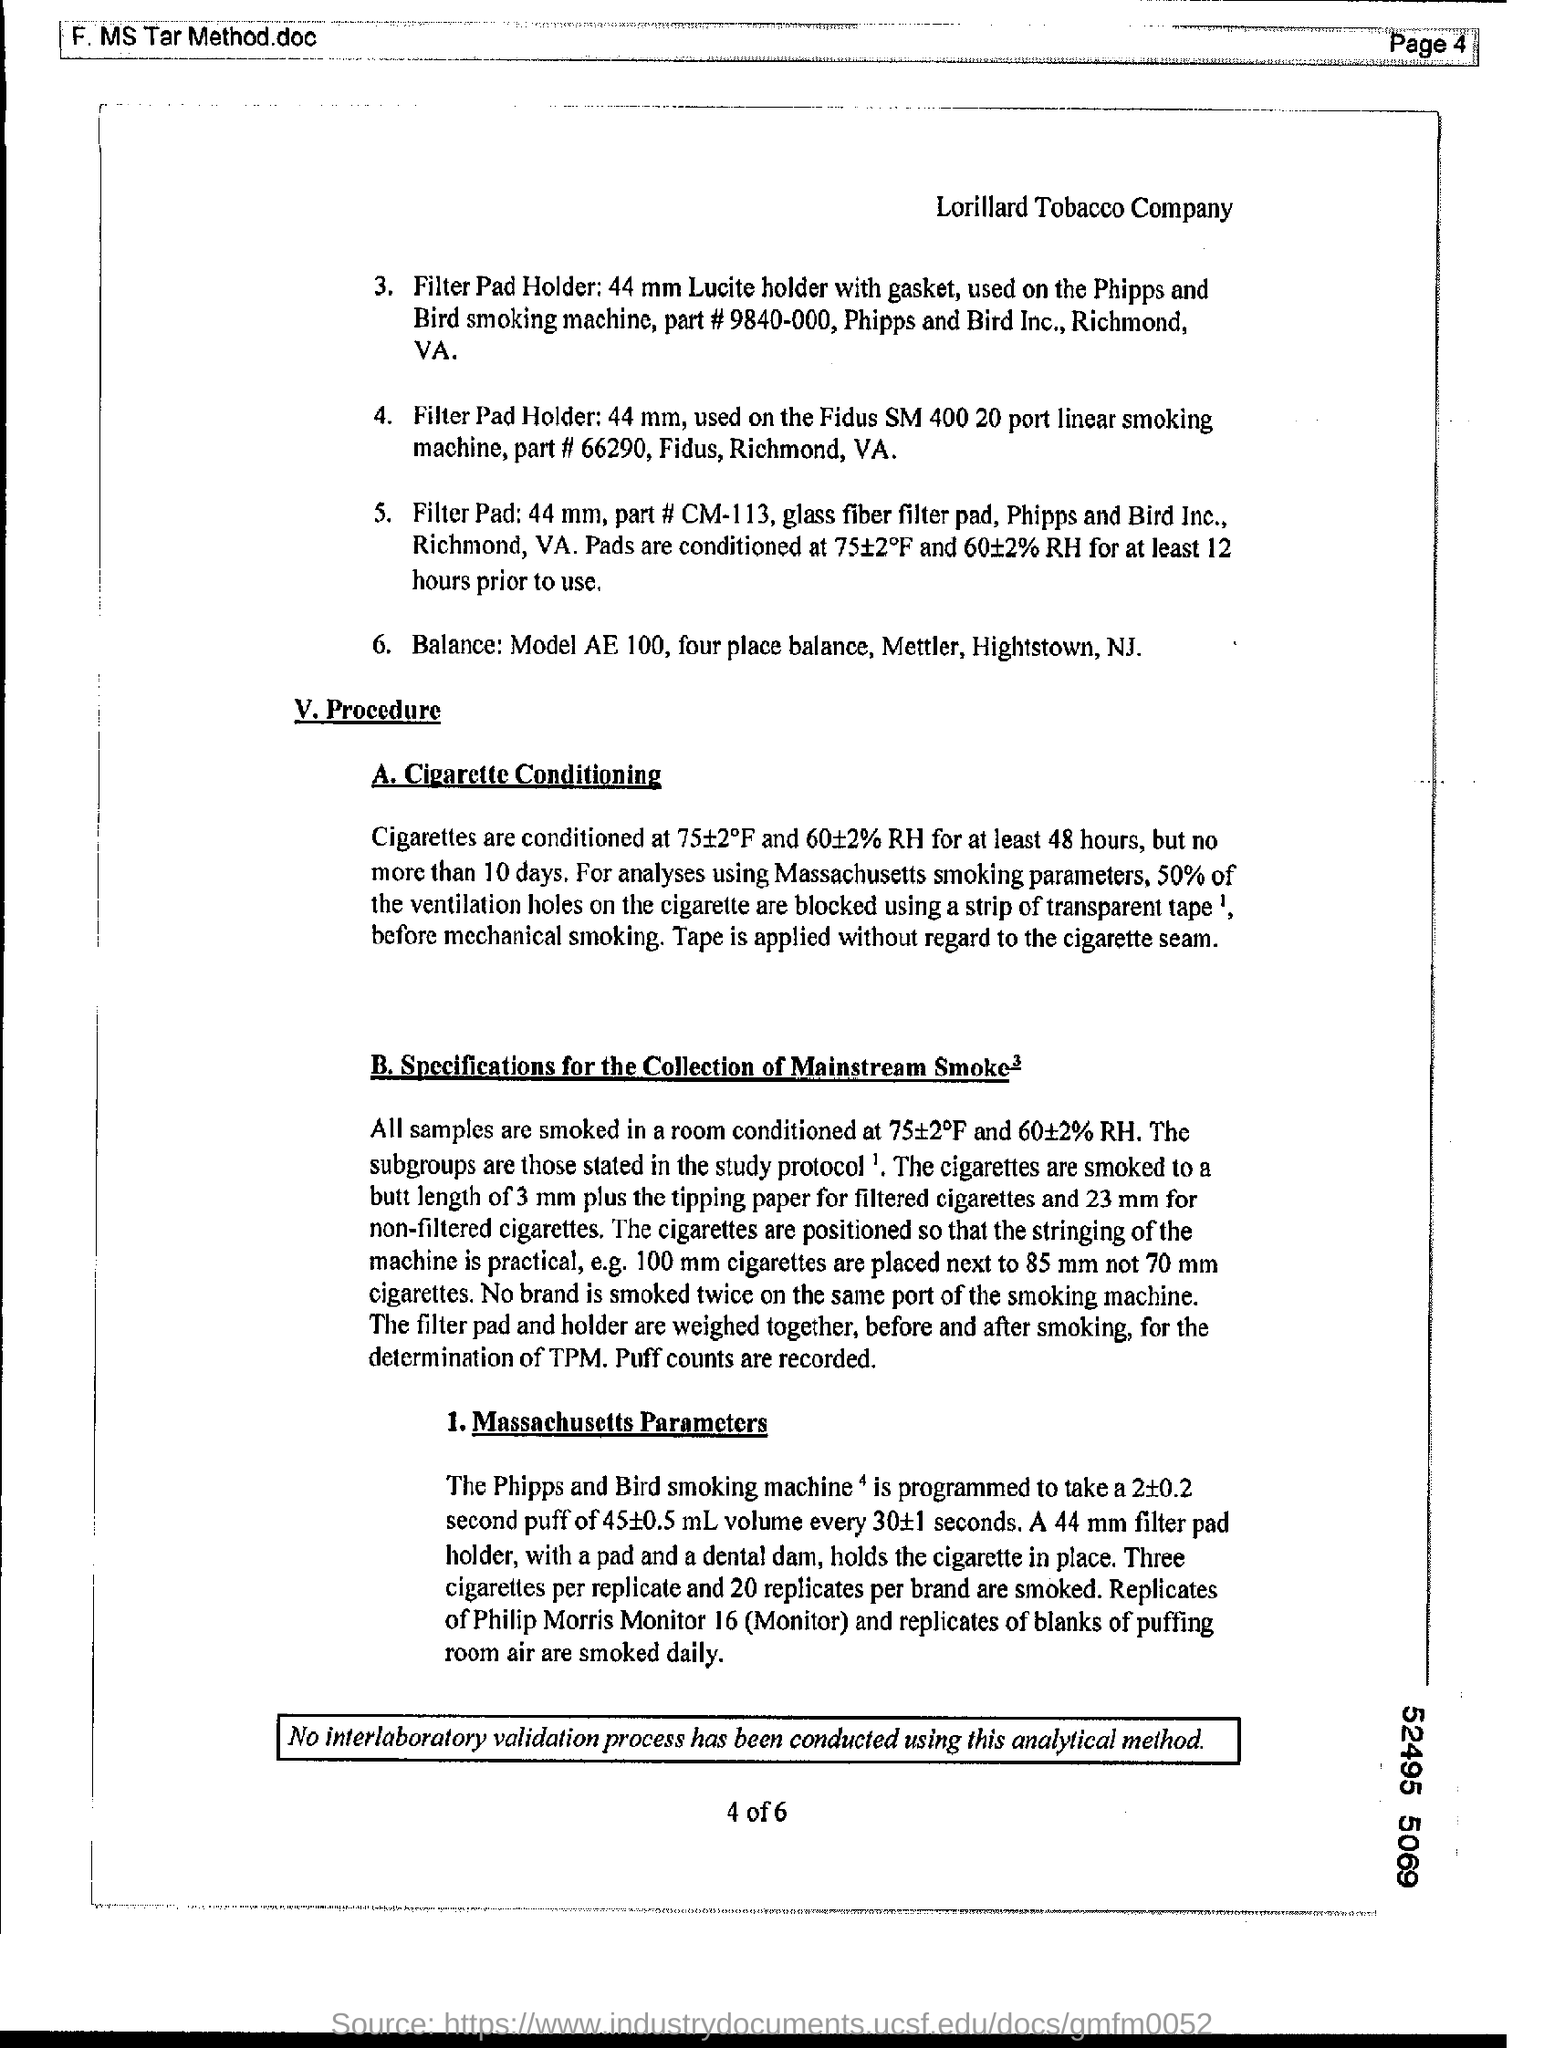How many hours Cigarettes are conditioned
Your answer should be compact. 48. What % of the ventilation holes on the cigarette are blocked
Your answer should be very brief. 50. 